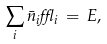Convert formula to latex. <formula><loc_0><loc_0><loc_500><loc_500>\sum _ { i } \bar { n } _ { i } \epsilon _ { i } \, = \, E ,</formula> 